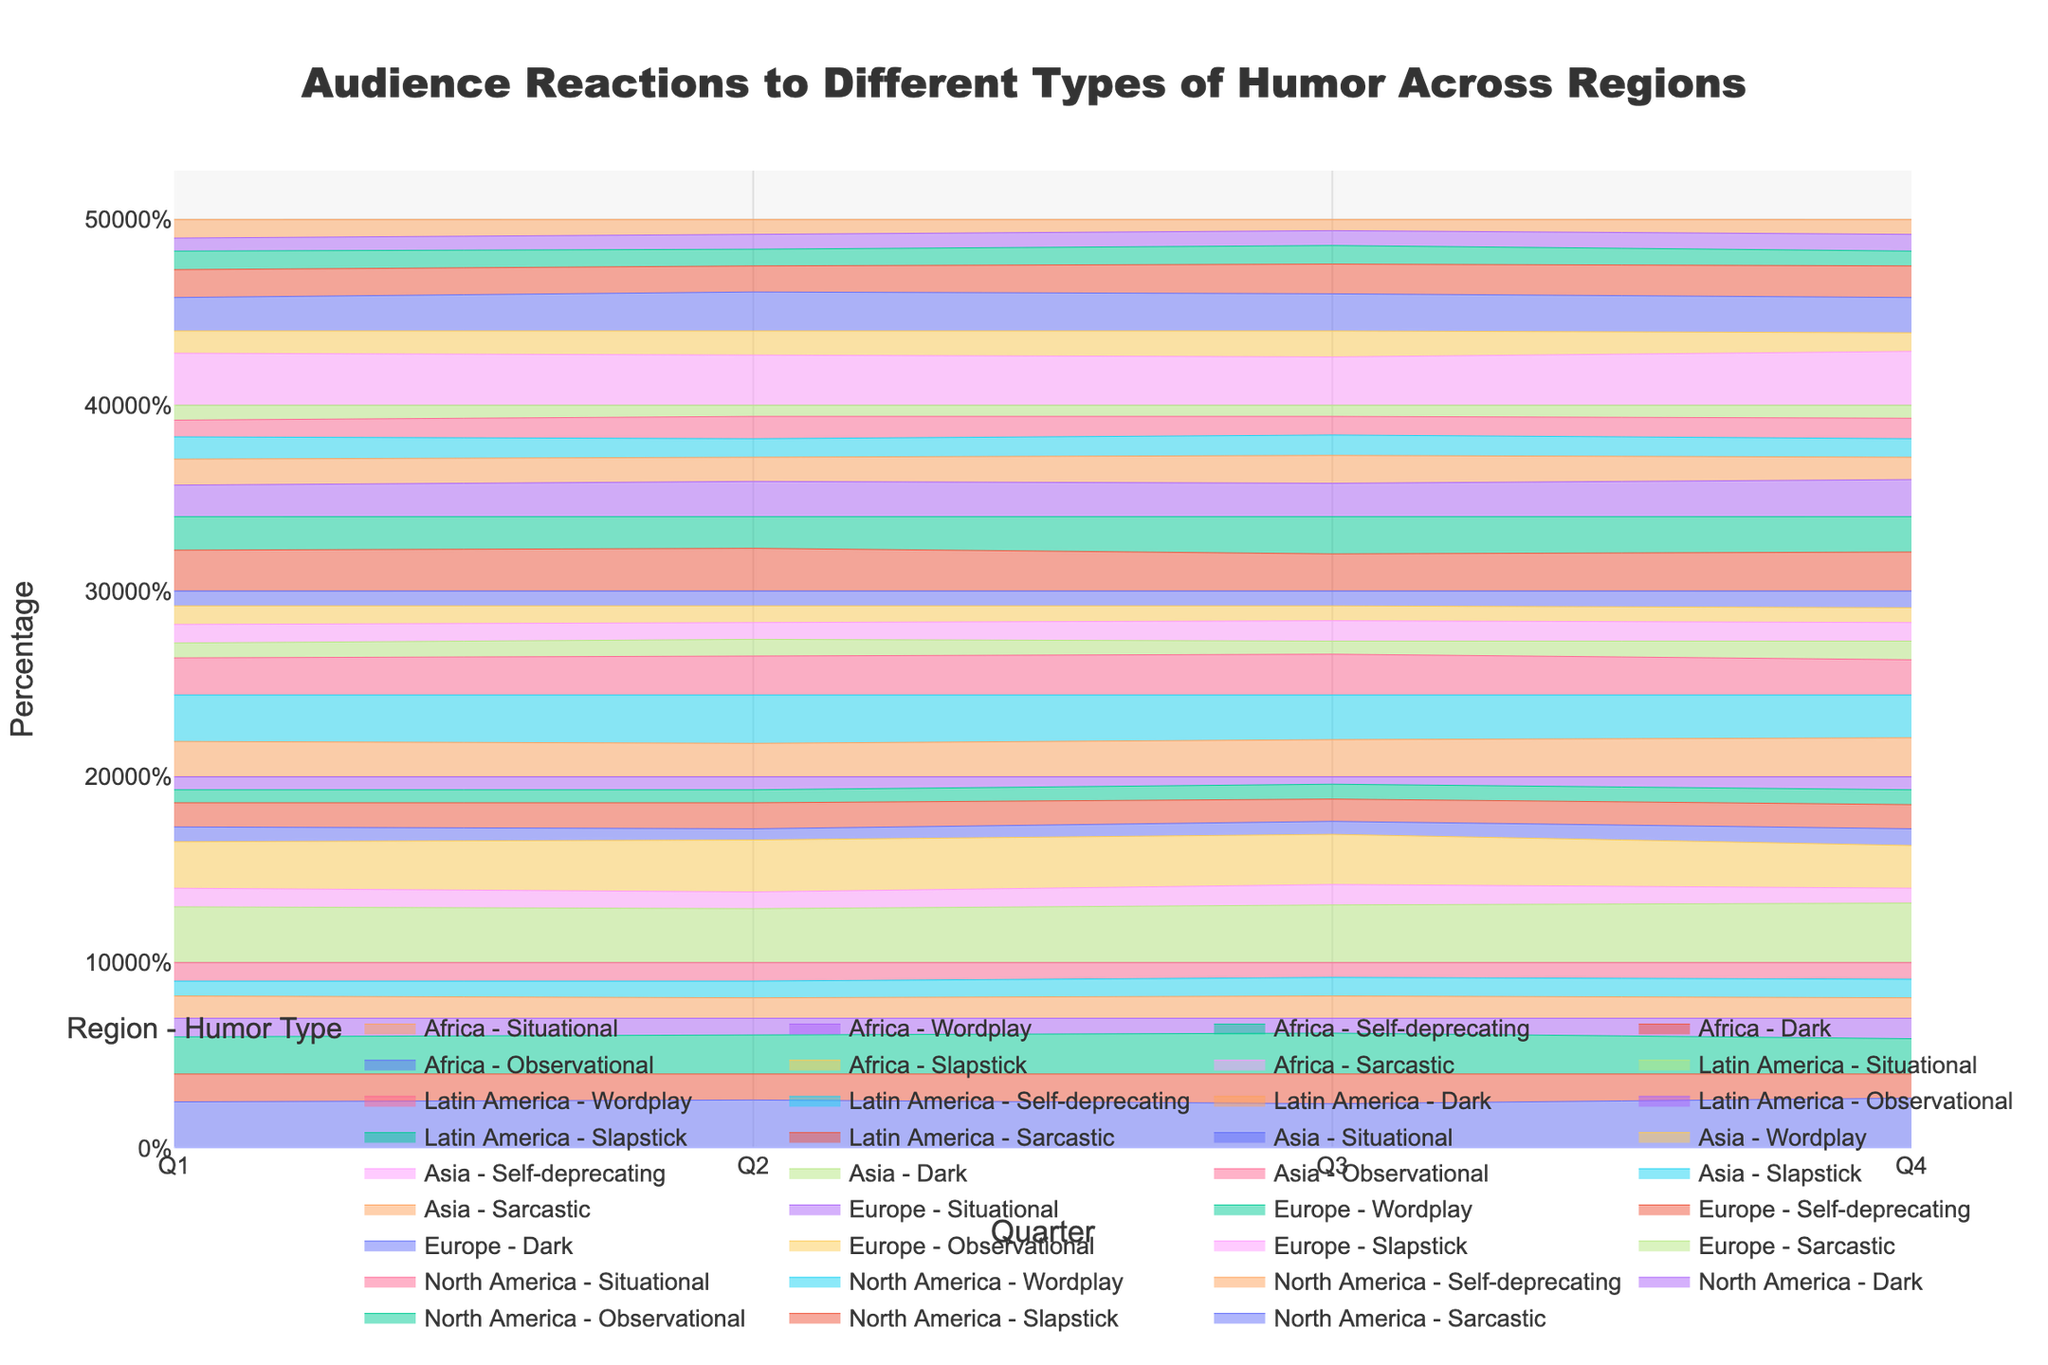What is the title of the figure? The title is often displayed at the top center of the figure. In this case, it reads "Audience Reactions to Different Types of Humor Across Regions".
Answer: Audience Reactions to Different Types of Humor Across Regions Which region has the highest percentage of Sarcastic humor overall? Looking at the different regions' lines in the 100% stacked area chart for Sarcastic humor, North America typically has the highest values throughout the quarters, closely followed by Europe. However, Europe tends to increase and surpass North America in some quarters.
Answer: Europe What type of humor has the most consistent percentage across all regions? Consistency can be determined by observing the smoothness and flatness of a humor type across all regions. Self-deprecating humor seems to have the least variation in value across quarters and regions in the figure.
Answer: Self-deprecating In which region does Slapstick humor have the highest percentage during Q1? By examining the Q1 data points for Slapstick humor across all regions, Asia has the highest value.
Answer: Asia Compare the popularity of Observational humor in North America and Europe in Q3. Which region prefers it more? Observational humor's percentage in Q3 for North America is 22%, whereas for Europe it is 27%. Hence, Europe shows a higher preference for Observational humor in Q3.
Answer: Europe What is the difference in Dark humor between Q1 and Q4 in Africa? To find the difference, subtract the Q1 value of Dark humor in Africa from the Q4 value. In Q1 it is 15%, and in Q4 it is 17%, so the difference is 17% - 15% = 2%.
Answer: 2% Which humor type sees the largest increase in percentage from Q1 to Q4 in North America? By comparing the percents for each type of humor in North America from Q1 to Q4, Sarcastic humor increases from 25% to 27%, which is the largest increase among all humor types in this region.
Answer: Sarcastic What is the most popular type of humor in Latin America during Q4? In Q4, Situational humor has the highest percentage in Latin America, followed by Observational.
Answer: Observational Is there any humor type that consistently decreases in popularity in Asia from Q1 to Q4? A steady decline over four quarters must be identified. Slapstick humor goes from 25% in Q1 to 23% in Q4, showing a consistent, though slight, decrease.
Answer: Slapstick How does Wordplay humor compare between Q2 in Asia and Q2 in Latin America? Wordplay humor's percentage in Q2 is 9% for Asia and 12% for Latin America, indicating that it is more popular in Latin America in that period.
Answer: Latin America 